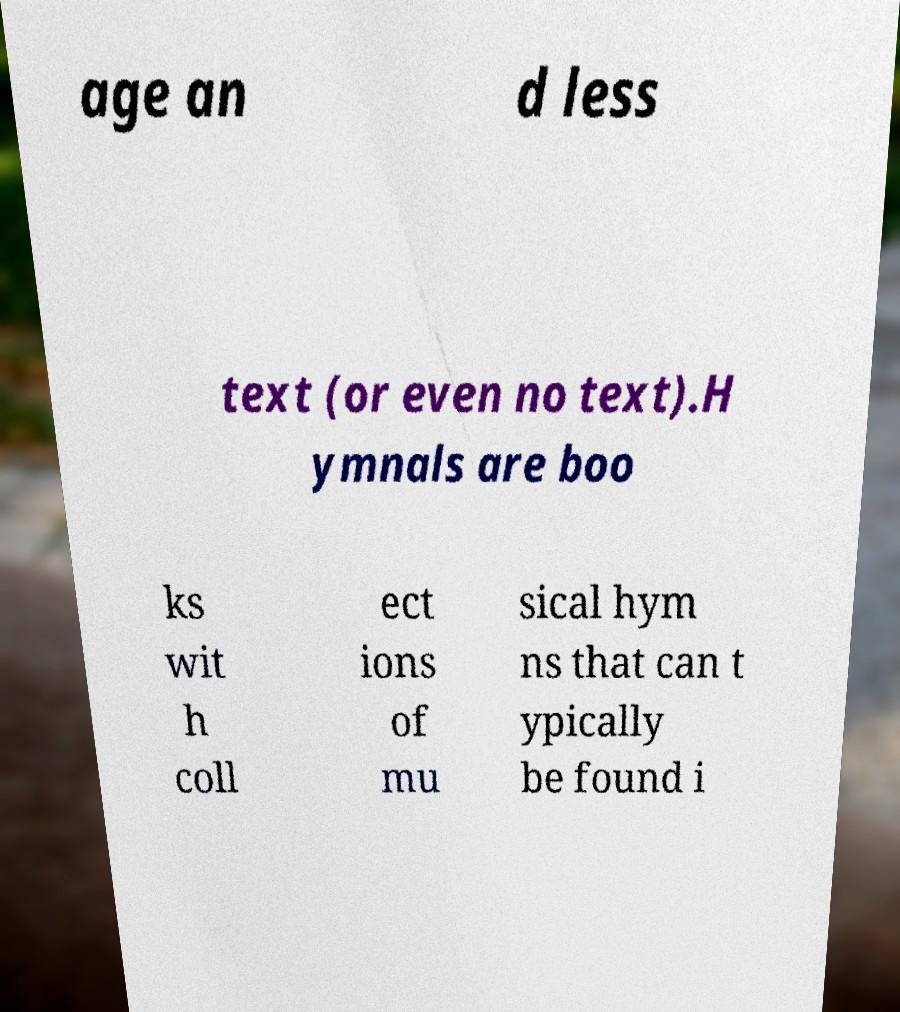Can you read and provide the text displayed in the image?This photo seems to have some interesting text. Can you extract and type it out for me? age an d less text (or even no text).H ymnals are boo ks wit h coll ect ions of mu sical hym ns that can t ypically be found i 